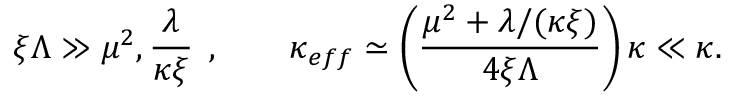Convert formula to latex. <formula><loc_0><loc_0><loc_500><loc_500>\xi \Lambda \gg \mu ^ { 2 } , \frac { \lambda } { \kappa \xi } \, , \quad \kappa _ { e f f } \simeq \left ( \frac { \mu ^ { 2 } + \lambda / ( \kappa \xi ) } { 4 \xi \Lambda } \right ) \kappa \ll \kappa .</formula> 